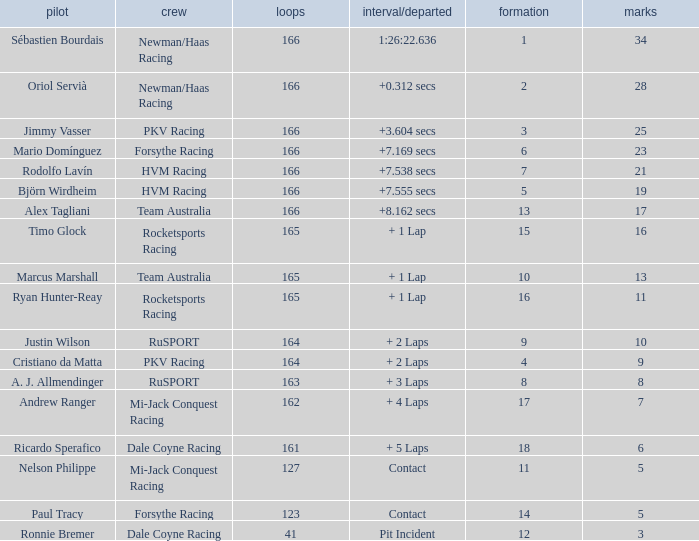What is the biggest points when the grid is less than 13 and the time/retired is +7.538 secs? 21.0. 